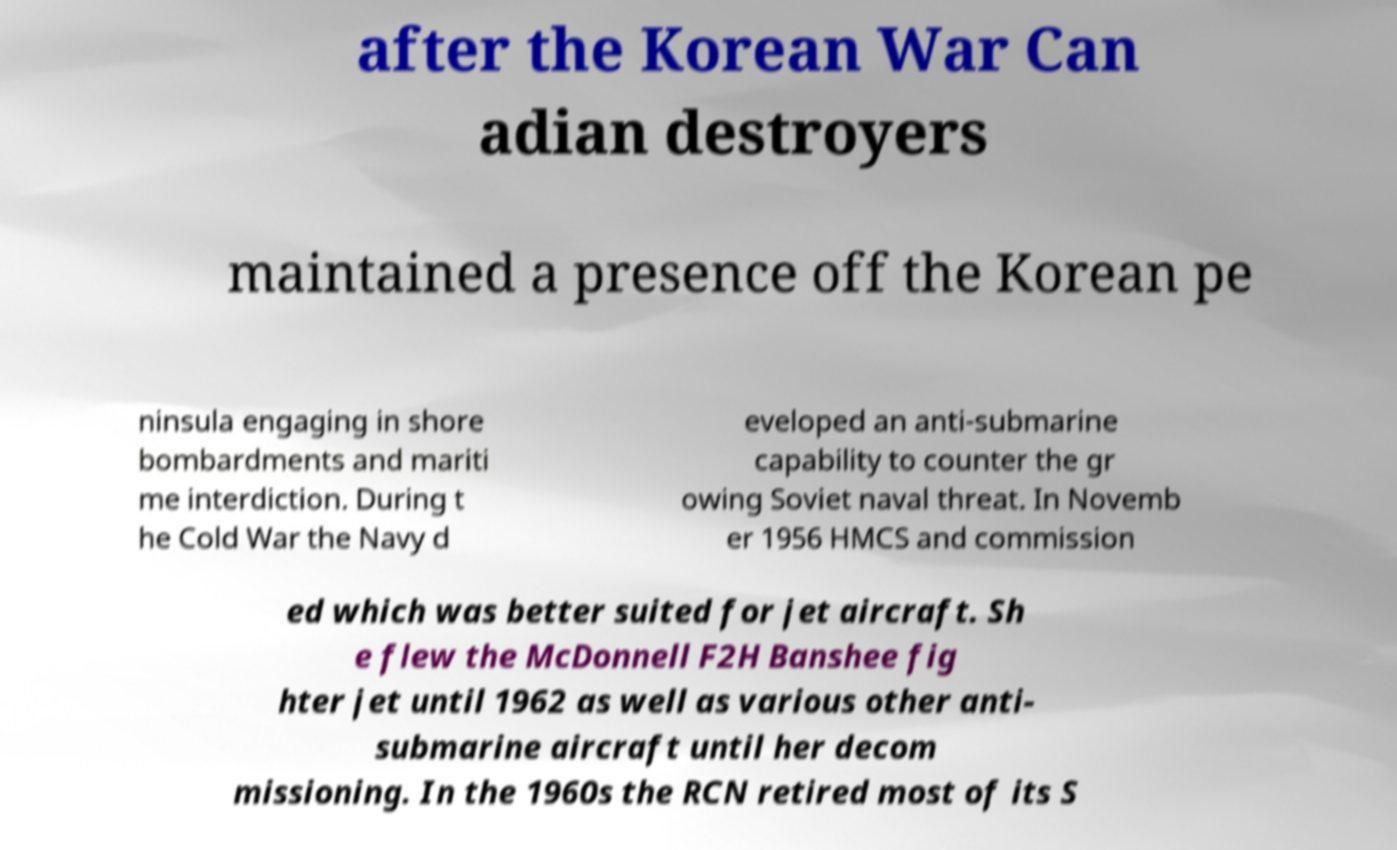Can you read and provide the text displayed in the image?This photo seems to have some interesting text. Can you extract and type it out for me? after the Korean War Can adian destroyers maintained a presence off the Korean pe ninsula engaging in shore bombardments and mariti me interdiction. During t he Cold War the Navy d eveloped an anti-submarine capability to counter the gr owing Soviet naval threat. In Novemb er 1956 HMCS and commission ed which was better suited for jet aircraft. Sh e flew the McDonnell F2H Banshee fig hter jet until 1962 as well as various other anti- submarine aircraft until her decom missioning. In the 1960s the RCN retired most of its S 